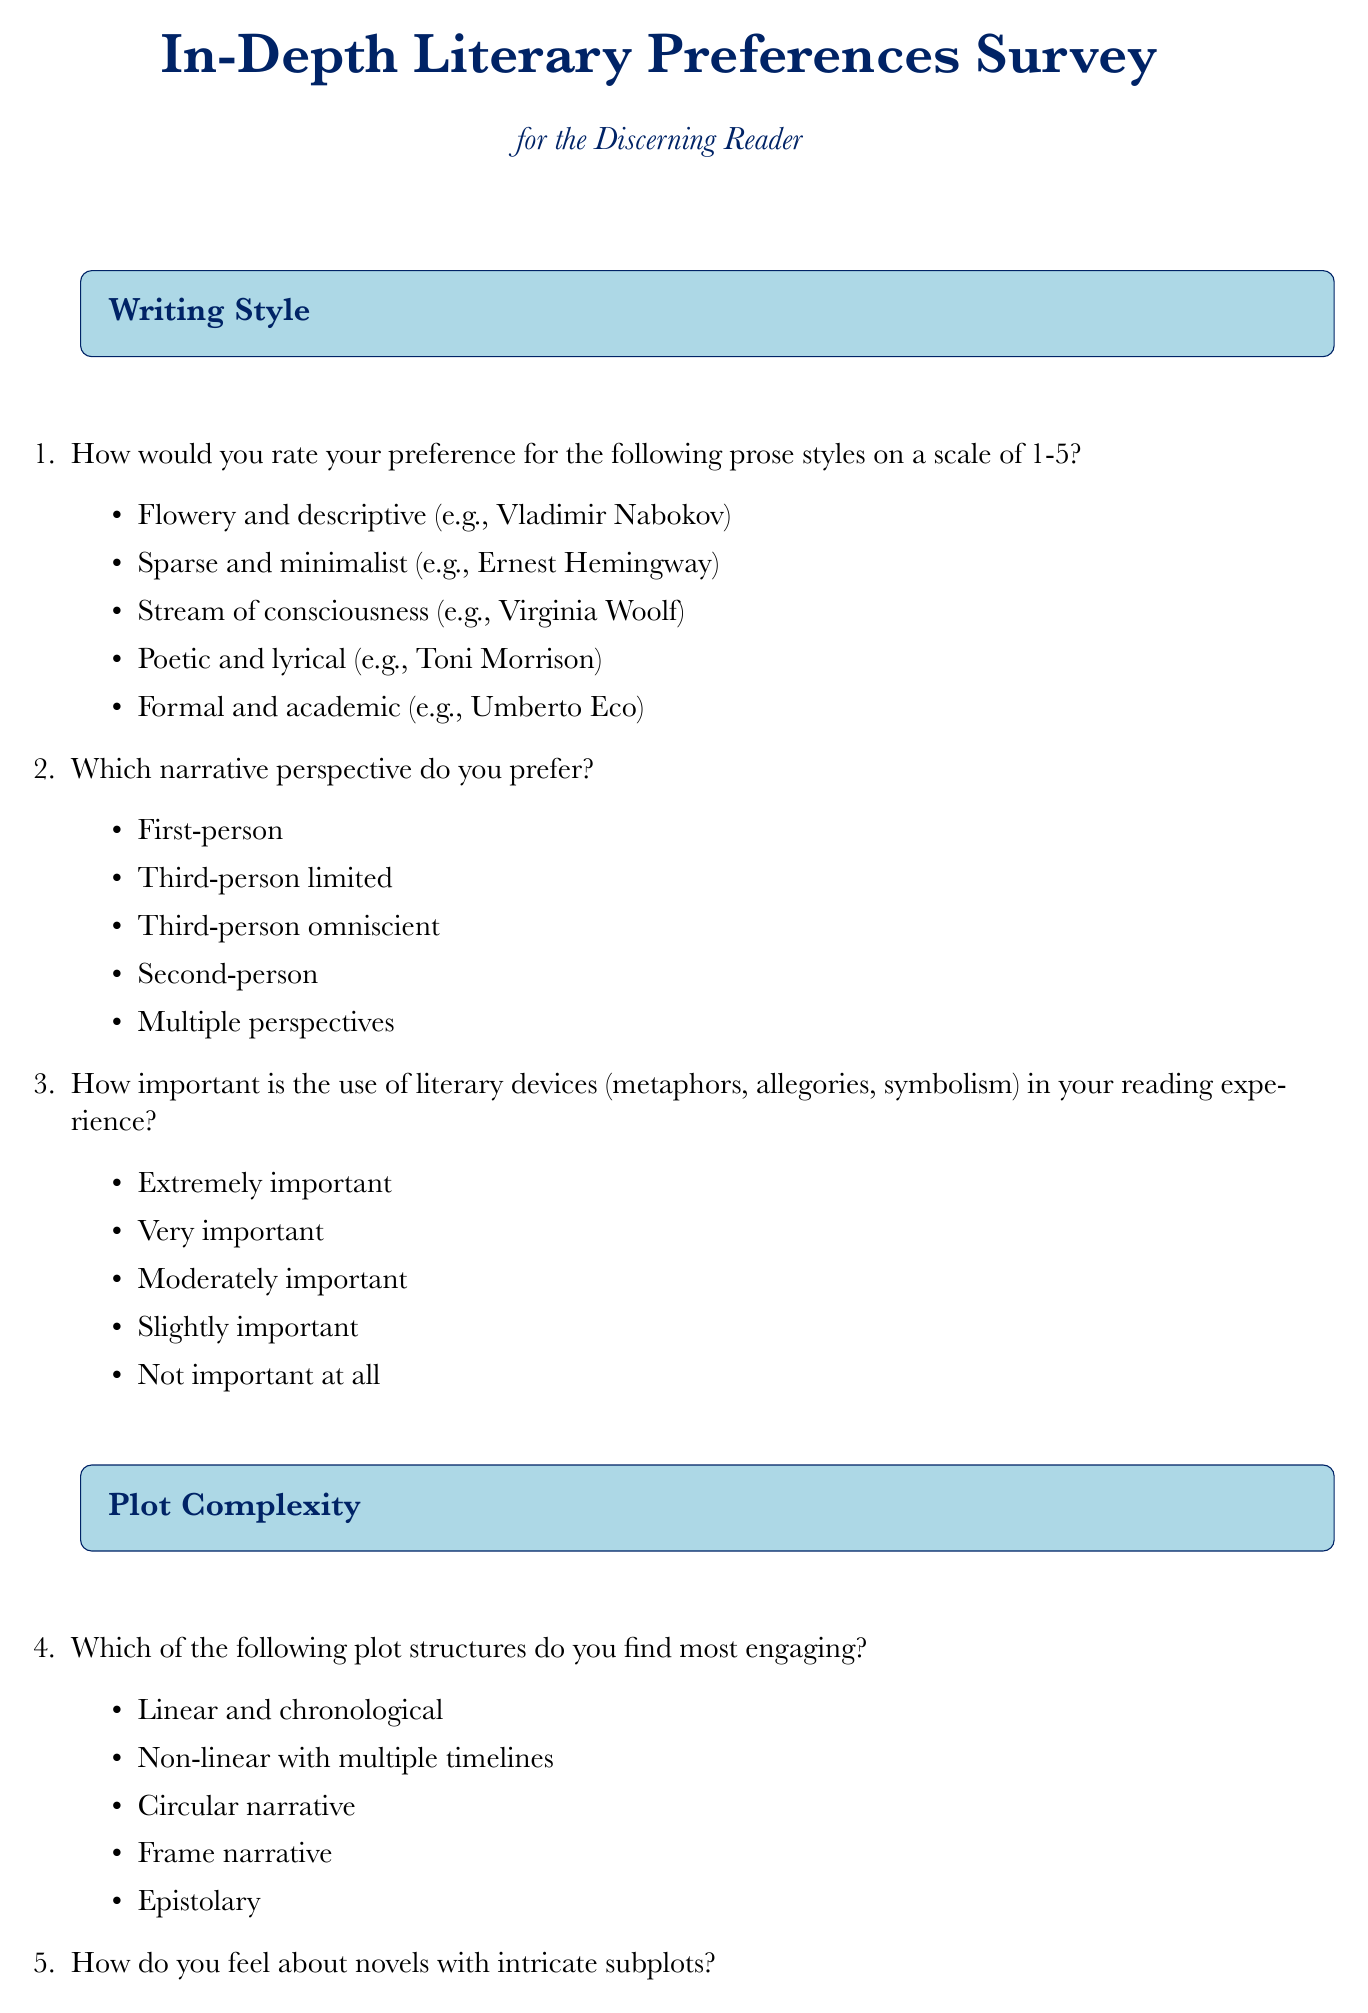What is the title of the questionnaire? The title is provided at the beginning of the document in large text.
Answer: In-Depth Literary Preferences Survey for the Discerning Reader How many sections are in the document? The document contains five distinct sections, each focusing on a different aspect of literary preferences.
Answer: 5 Which character archetype is listed first in the Character Archetypes section? The first character type mentioned is presented in a list format under the Character Archetypes section.
Answer: Antihero What theme is listed last in the Thematic Preferences section? The final theme appears at the end of the list provided in the Thematic Preferences section.
Answer: Societal critique What type of literary periods does the Literary Period and Cultural Context section include? The document lists specific literary periods as options under the corresponding section title.
Answer: Classical, Renaissance, Romanticism, Modernism, Contemporary How important is the use of literary devices to the reader based on their responses? The importance level is assessed through a question in the Writing Style section, allowing for rated responses.
Answer: Extremely important Which narrative perspective is preferred the least based on the options provided? The least preferred narrative perspective can be inferred from the options in the Writing Style section.
Answer: Second-person What is the rating scale for prose style preferences? The rating scale is defined in one of the survey questions, indicating how respondents should express their preferences.
Answer: 1-5 What response option is associated with enjoying complex plots? This option is found under the question regarding feelings towards intricate subplots.
Answer: Love them - the more complex, the better 